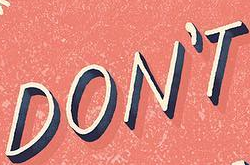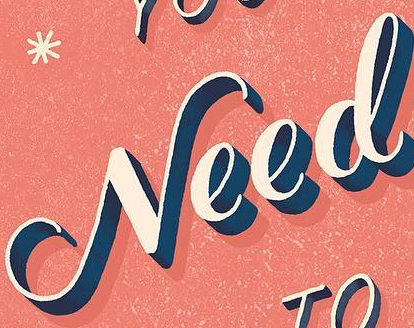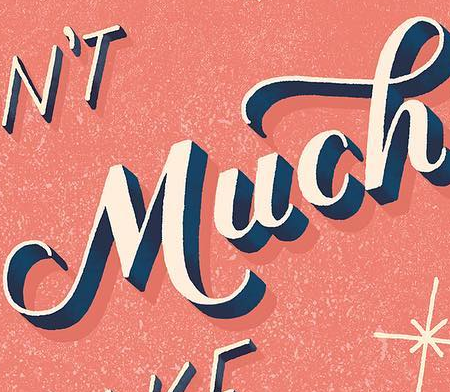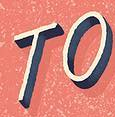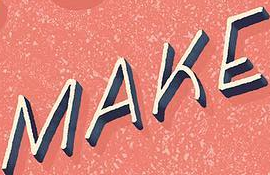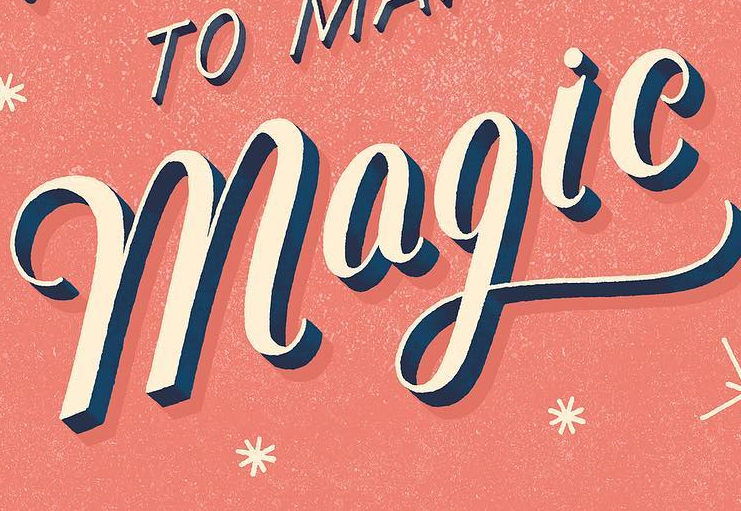What words are shown in these images in order, separated by a semicolon? DON'T; Need; Much; TO; MAKE; magic 